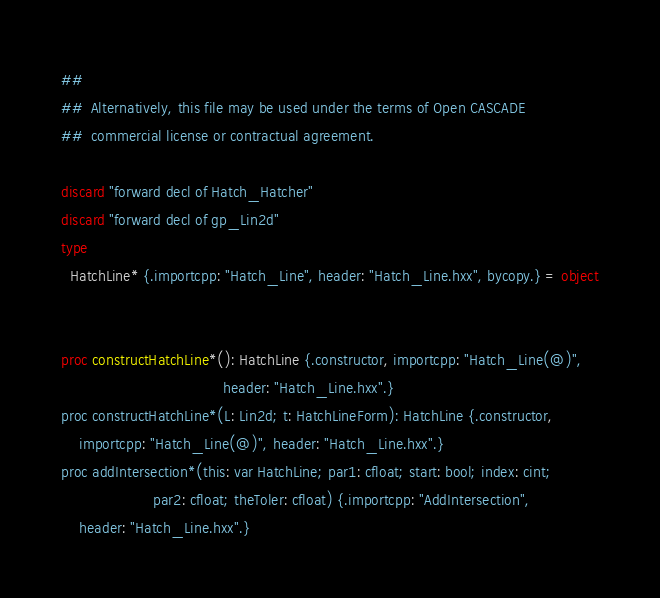Convert code to text. <code><loc_0><loc_0><loc_500><loc_500><_Nim_>##
##  Alternatively, this file may be used under the terms of Open CASCADE
##  commercial license or contractual agreement.

discard "forward decl of Hatch_Hatcher"
discard "forward decl of gp_Lin2d"
type
  HatchLine* {.importcpp: "Hatch_Line", header: "Hatch_Line.hxx", bycopy.} = object


proc constructHatchLine*(): HatchLine {.constructor, importcpp: "Hatch_Line(@)",
                                     header: "Hatch_Line.hxx".}
proc constructHatchLine*(L: Lin2d; t: HatchLineForm): HatchLine {.constructor,
    importcpp: "Hatch_Line(@)", header: "Hatch_Line.hxx".}
proc addIntersection*(this: var HatchLine; par1: cfloat; start: bool; index: cint;
                     par2: cfloat; theToler: cfloat) {.importcpp: "AddIntersection",
    header: "Hatch_Line.hxx".}

























</code> 